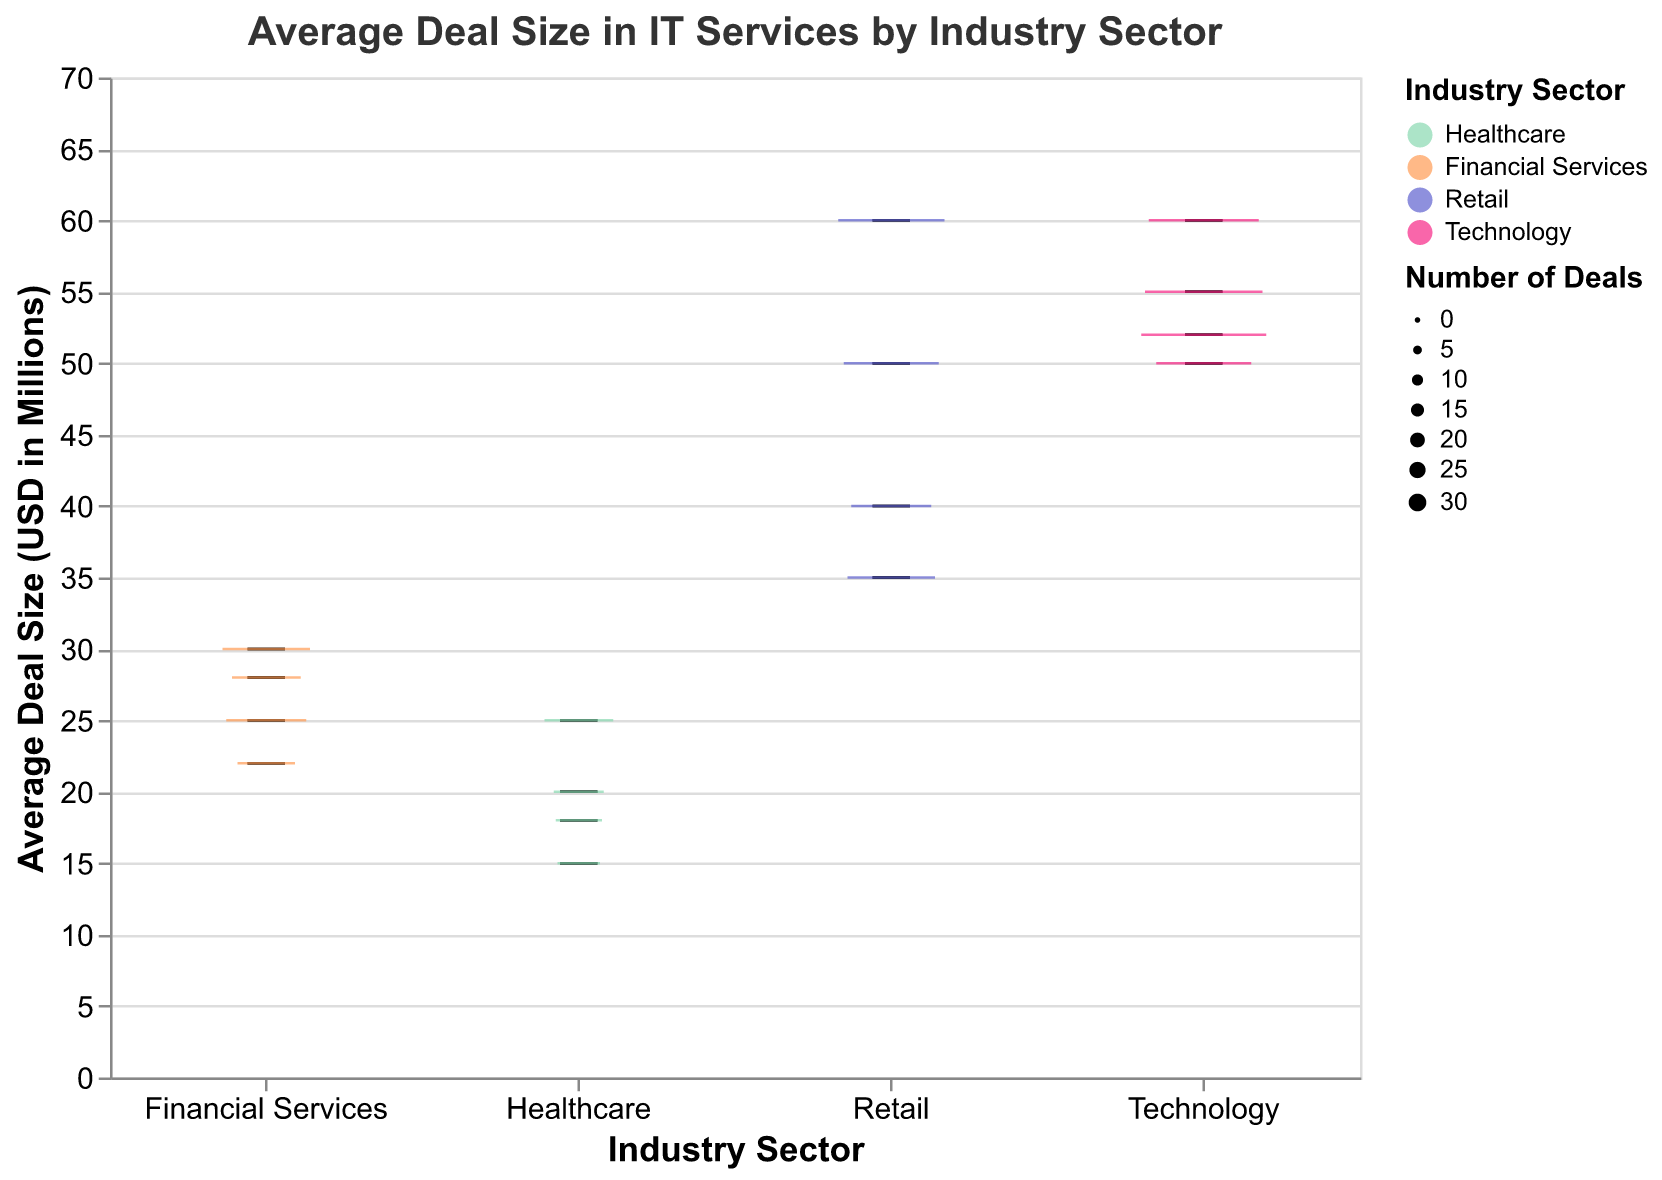What is the highest average deal size in the Healthcare sector? The highest average deal size in the Healthcare sector can be found by looking at the upper part of the boxplot for the Healthcare sector.
Answer: 25 million USD Which sector has the widest variation in average deal sizes? The sector with the widest variation in average deal sizes can be determined by comparing the vertical spans of the boxplots for each sector.
Answer: Retail In which sector is the company with the largest average deal size overall? To find the sector with the largest overall average deal size, we need to look for the highest point on the y-axis.
Answer: Retail How many deals did the company with the smallest average deal size in the Financial Services sector make? The smallest average deal size in the Financial Services sector can be found at the bottom of its boxplot. The number of deals is represented by the width of the boxplot.
Answer: 12 Which sector has the highest median average deal size? The sector with the highest median average deal size can be identified by the highest median line within a boxplot.
Answer: Retail What is the range of average deal sizes in the Technology sector? The range can be calculated by subtracting the lowest value of the lower whisker from the highest value of the upper whisker in the Technology sector's boxplot.
Answer: 60 - 50 = 10 million USD How does the number of deals affect the appearance of the boxplots? The width of the boxplots varies with the number of deals; more deals result in a wider boxplot. This correlates the visual size with the dataset size.
Answer: Wider boxplots represent more deals Which sector has the company with the highest number of deals, and how many deals are there? The company with the highest number of deals will correspond to the widest boxplot. Identify the sector and this specific company.
Answer: Technology, Microsoft - 30 deals Compare the median average deal sizes between Retail and Healthcare sectors. Locate the median lines in the boxplots for both Retail and Healthcare sectors. Compare the heights of these lines on the y-axis.
Answer: Retail has a higher median average deal size: Retail (around 50 million USD); Healthcare (around 18 million USD) What can you infer about the average deal sizes in the Technology sector compared to the other sectors? Compared to other sectors, the Technology sector has relatively high average deal sizes with a narrow range, indicating less variation. The boxplot appears centered in a higher average deal size range.
Answer: Higher average deal sizes with less variation compared to others 